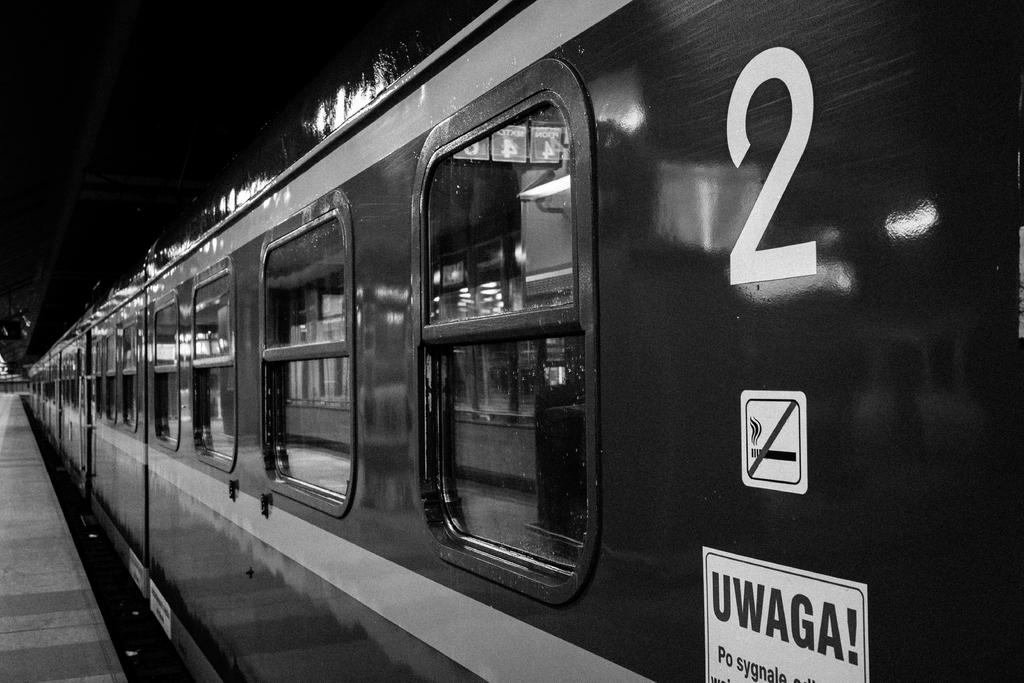<image>
Render a clear and concise summary of the photo. a train with the number 2 written across 